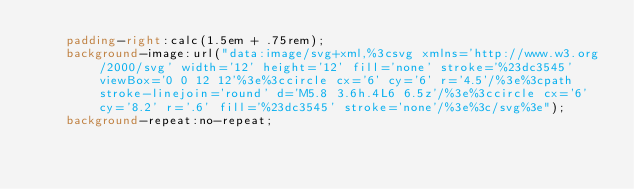Convert code to text. <code><loc_0><loc_0><loc_500><loc_500><_CSS_>    padding-right:calc(1.5em + .75rem);
    background-image:url("data:image/svg+xml,%3csvg xmlns='http://www.w3.org/2000/svg' width='12' height='12' fill='none' stroke='%23dc3545' viewBox='0 0 12 12'%3e%3ccircle cx='6' cy='6' r='4.5'/%3e%3cpath stroke-linejoin='round' d='M5.8 3.6h.4L6 6.5z'/%3e%3ccircle cx='6' cy='8.2' r='.6' fill='%23dc3545' stroke='none'/%3e%3c/svg%3e");
    background-repeat:no-repeat;</code> 